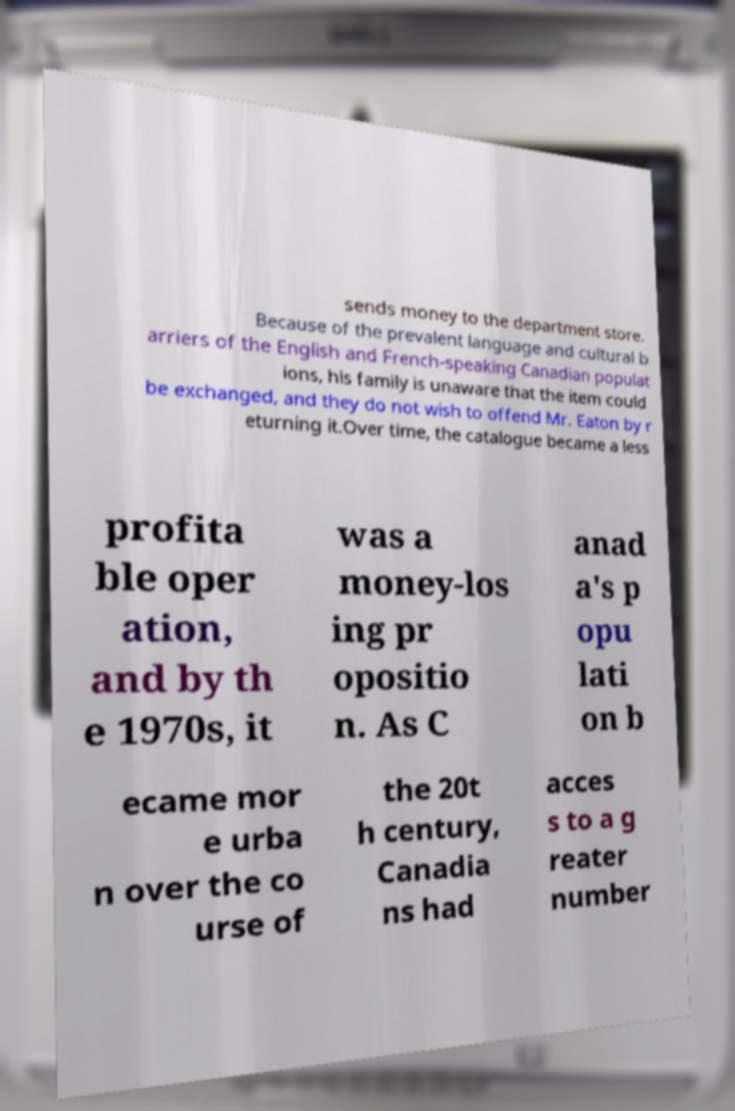There's text embedded in this image that I need extracted. Can you transcribe it verbatim? sends money to the department store. Because of the prevalent language and cultural b arriers of the English and French-speaking Canadian populat ions, his family is unaware that the item could be exchanged, and they do not wish to offend Mr. Eaton by r eturning it.Over time, the catalogue became a less profita ble oper ation, and by th e 1970s, it was a money-los ing pr opositio n. As C anad a's p opu lati on b ecame mor e urba n over the co urse of the 20t h century, Canadia ns had acces s to a g reater number 